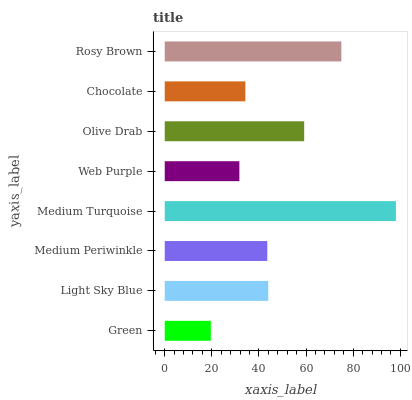Is Green the minimum?
Answer yes or no. Yes. Is Medium Turquoise the maximum?
Answer yes or no. Yes. Is Light Sky Blue the minimum?
Answer yes or no. No. Is Light Sky Blue the maximum?
Answer yes or no. No. Is Light Sky Blue greater than Green?
Answer yes or no. Yes. Is Green less than Light Sky Blue?
Answer yes or no. Yes. Is Green greater than Light Sky Blue?
Answer yes or no. No. Is Light Sky Blue less than Green?
Answer yes or no. No. Is Light Sky Blue the high median?
Answer yes or no. Yes. Is Medium Periwinkle the low median?
Answer yes or no. Yes. Is Web Purple the high median?
Answer yes or no. No. Is Medium Turquoise the low median?
Answer yes or no. No. 